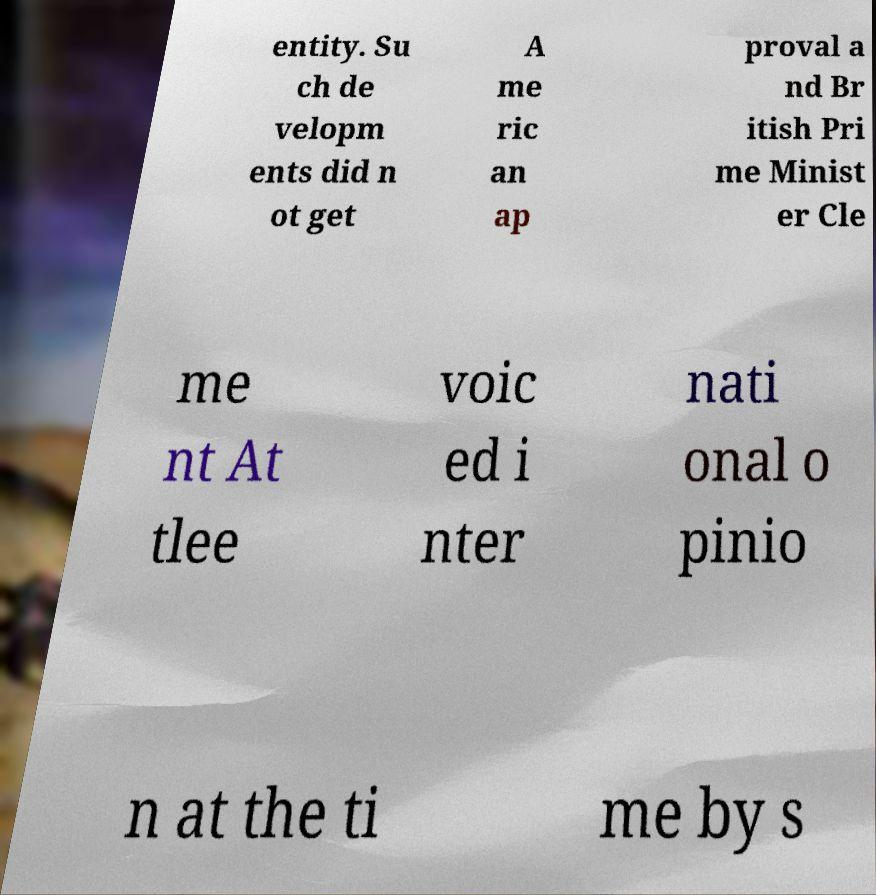Please read and relay the text visible in this image. What does it say? entity. Su ch de velopm ents did n ot get A me ric an ap proval a nd Br itish Pri me Minist er Cle me nt At tlee voic ed i nter nati onal o pinio n at the ti me by s 